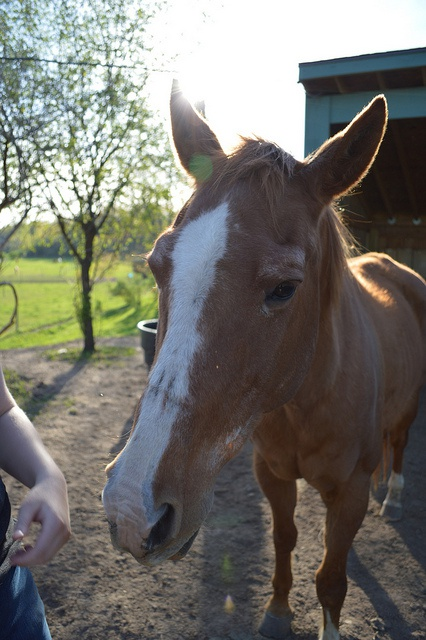Describe the objects in this image and their specific colors. I can see horse in darkgray, black, and gray tones and people in darkgray, gray, black, and navy tones in this image. 